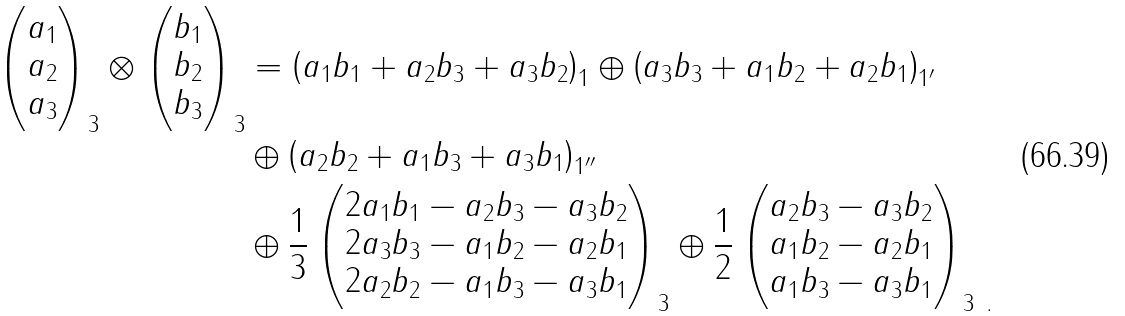<formula> <loc_0><loc_0><loc_500><loc_500>\begin{pmatrix} a _ { 1 } \\ a _ { 2 } \\ a _ { 3 } \end{pmatrix} _ { 3 } \otimes \begin{pmatrix} b _ { 1 } \\ b _ { 2 } \\ b _ { 3 } \end{pmatrix} _ { 3 } & = \left ( a _ { 1 } b _ { 1 } + a _ { 2 } b _ { 3 } + a _ { 3 } b _ { 2 } \right ) _ { 1 } \oplus \left ( a _ { 3 } b _ { 3 } + a _ { 1 } b _ { 2 } + a _ { 2 } b _ { 1 } \right ) _ { { 1 } ^ { \prime } } \\ & \oplus \left ( a _ { 2 } b _ { 2 } + a _ { 1 } b _ { 3 } + a _ { 3 } b _ { 1 } \right ) _ { { 1 } ^ { \prime \prime } } \\ & \oplus \frac { 1 } { 3 } \begin{pmatrix} 2 a _ { 1 } b _ { 1 } - a _ { 2 } b _ { 3 } - a _ { 3 } b _ { 2 } \\ 2 a _ { 3 } b _ { 3 } - a _ { 1 } b _ { 2 } - a _ { 2 } b _ { 1 } \\ 2 a _ { 2 } b _ { 2 } - a _ { 1 } b _ { 3 } - a _ { 3 } b _ { 1 } \end{pmatrix} _ { 3 } \oplus \frac { 1 } { 2 } \begin{pmatrix} a _ { 2 } b _ { 3 } - a _ { 3 } b _ { 2 } \\ a _ { 1 } b _ { 2 } - a _ { 2 } b _ { 1 } \\ a _ { 1 } b _ { 3 } - a _ { 3 } b _ { 1 } \end{pmatrix} _ { { 3 } \ . }</formula> 